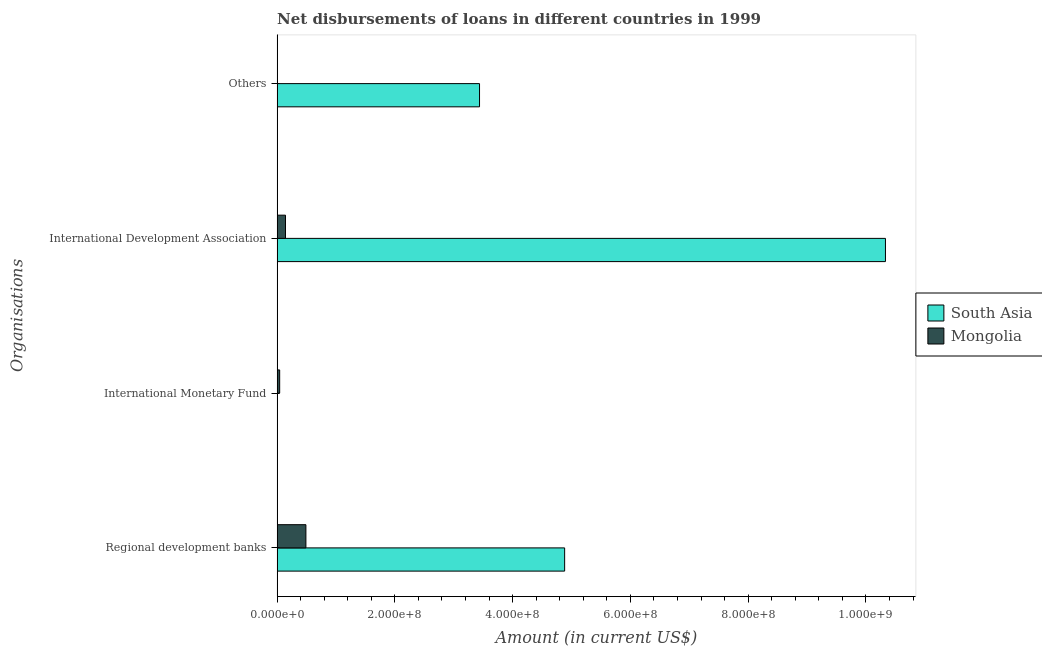How many different coloured bars are there?
Give a very brief answer. 2. Are the number of bars per tick equal to the number of legend labels?
Give a very brief answer. No. Are the number of bars on each tick of the Y-axis equal?
Keep it short and to the point. No. How many bars are there on the 4th tick from the top?
Ensure brevity in your answer.  2. How many bars are there on the 4th tick from the bottom?
Keep it short and to the point. 2. What is the label of the 1st group of bars from the top?
Offer a terse response. Others. What is the amount of loan disimbursed by other organisations in South Asia?
Ensure brevity in your answer.  3.44e+08. Across all countries, what is the maximum amount of loan disimbursed by other organisations?
Provide a short and direct response. 3.44e+08. Across all countries, what is the minimum amount of loan disimbursed by regional development banks?
Offer a very short reply. 4.89e+07. In which country was the amount of loan disimbursed by international development association maximum?
Your answer should be very brief. South Asia. What is the total amount of loan disimbursed by international development association in the graph?
Your answer should be very brief. 1.05e+09. What is the difference between the amount of loan disimbursed by other organisations in South Asia and that in Mongolia?
Offer a terse response. 3.43e+08. What is the difference between the amount of loan disimbursed by international monetary fund in Mongolia and the amount of loan disimbursed by other organisations in South Asia?
Offer a very short reply. -3.39e+08. What is the average amount of loan disimbursed by regional development banks per country?
Offer a terse response. 2.69e+08. What is the difference between the amount of loan disimbursed by regional development banks and amount of loan disimbursed by international development association in Mongolia?
Your answer should be very brief. 3.47e+07. What is the ratio of the amount of loan disimbursed by other organisations in Mongolia to that in South Asia?
Provide a short and direct response. 0. Is the amount of loan disimbursed by other organisations in South Asia less than that in Mongolia?
Provide a short and direct response. No. What is the difference between the highest and the second highest amount of loan disimbursed by international development association?
Make the answer very short. 1.02e+09. What is the difference between the highest and the lowest amount of loan disimbursed by other organisations?
Offer a very short reply. 3.43e+08. In how many countries, is the amount of loan disimbursed by international monetary fund greater than the average amount of loan disimbursed by international monetary fund taken over all countries?
Your answer should be compact. 1. Is it the case that in every country, the sum of the amount of loan disimbursed by regional development banks and amount of loan disimbursed by international monetary fund is greater than the amount of loan disimbursed by international development association?
Make the answer very short. No. Are all the bars in the graph horizontal?
Provide a short and direct response. Yes. How many countries are there in the graph?
Your answer should be very brief. 2. What is the difference between two consecutive major ticks on the X-axis?
Offer a terse response. 2.00e+08. Does the graph contain any zero values?
Make the answer very short. Yes. Where does the legend appear in the graph?
Provide a short and direct response. Center right. How many legend labels are there?
Your answer should be very brief. 2. What is the title of the graph?
Keep it short and to the point. Net disbursements of loans in different countries in 1999. What is the label or title of the Y-axis?
Offer a terse response. Organisations. What is the Amount (in current US$) of South Asia in Regional development banks?
Provide a succinct answer. 4.88e+08. What is the Amount (in current US$) of Mongolia in Regional development banks?
Offer a terse response. 4.89e+07. What is the Amount (in current US$) in South Asia in International Monetary Fund?
Your answer should be very brief. 0. What is the Amount (in current US$) in Mongolia in International Monetary Fund?
Your answer should be compact. 4.31e+06. What is the Amount (in current US$) of South Asia in International Development Association?
Keep it short and to the point. 1.03e+09. What is the Amount (in current US$) of Mongolia in International Development Association?
Offer a terse response. 1.42e+07. What is the Amount (in current US$) in South Asia in Others?
Keep it short and to the point. 3.44e+08. What is the Amount (in current US$) in Mongolia in Others?
Your answer should be very brief. 5.68e+05. Across all Organisations, what is the maximum Amount (in current US$) of South Asia?
Provide a succinct answer. 1.03e+09. Across all Organisations, what is the maximum Amount (in current US$) of Mongolia?
Provide a succinct answer. 4.89e+07. Across all Organisations, what is the minimum Amount (in current US$) of South Asia?
Make the answer very short. 0. Across all Organisations, what is the minimum Amount (in current US$) in Mongolia?
Ensure brevity in your answer.  5.68e+05. What is the total Amount (in current US$) in South Asia in the graph?
Provide a short and direct response. 1.87e+09. What is the total Amount (in current US$) of Mongolia in the graph?
Give a very brief answer. 6.80e+07. What is the difference between the Amount (in current US$) of Mongolia in Regional development banks and that in International Monetary Fund?
Make the answer very short. 4.46e+07. What is the difference between the Amount (in current US$) of South Asia in Regional development banks and that in International Development Association?
Your answer should be very brief. -5.45e+08. What is the difference between the Amount (in current US$) of Mongolia in Regional development banks and that in International Development Association?
Offer a terse response. 3.47e+07. What is the difference between the Amount (in current US$) in South Asia in Regional development banks and that in Others?
Provide a short and direct response. 1.45e+08. What is the difference between the Amount (in current US$) in Mongolia in Regional development banks and that in Others?
Offer a very short reply. 4.83e+07. What is the difference between the Amount (in current US$) of Mongolia in International Monetary Fund and that in International Development Association?
Offer a terse response. -9.91e+06. What is the difference between the Amount (in current US$) of Mongolia in International Monetary Fund and that in Others?
Offer a very short reply. 3.74e+06. What is the difference between the Amount (in current US$) in South Asia in International Development Association and that in Others?
Your answer should be very brief. 6.89e+08. What is the difference between the Amount (in current US$) in Mongolia in International Development Association and that in Others?
Give a very brief answer. 1.37e+07. What is the difference between the Amount (in current US$) in South Asia in Regional development banks and the Amount (in current US$) in Mongolia in International Monetary Fund?
Make the answer very short. 4.84e+08. What is the difference between the Amount (in current US$) in South Asia in Regional development banks and the Amount (in current US$) in Mongolia in International Development Association?
Your answer should be compact. 4.74e+08. What is the difference between the Amount (in current US$) of South Asia in Regional development banks and the Amount (in current US$) of Mongolia in Others?
Keep it short and to the point. 4.88e+08. What is the difference between the Amount (in current US$) of South Asia in International Development Association and the Amount (in current US$) of Mongolia in Others?
Keep it short and to the point. 1.03e+09. What is the average Amount (in current US$) of South Asia per Organisations?
Ensure brevity in your answer.  4.66e+08. What is the average Amount (in current US$) in Mongolia per Organisations?
Your answer should be compact. 1.70e+07. What is the difference between the Amount (in current US$) in South Asia and Amount (in current US$) in Mongolia in Regional development banks?
Ensure brevity in your answer.  4.39e+08. What is the difference between the Amount (in current US$) of South Asia and Amount (in current US$) of Mongolia in International Development Association?
Give a very brief answer. 1.02e+09. What is the difference between the Amount (in current US$) of South Asia and Amount (in current US$) of Mongolia in Others?
Your answer should be very brief. 3.43e+08. What is the ratio of the Amount (in current US$) in Mongolia in Regional development banks to that in International Monetary Fund?
Your answer should be compact. 11.34. What is the ratio of the Amount (in current US$) in South Asia in Regional development banks to that in International Development Association?
Make the answer very short. 0.47. What is the ratio of the Amount (in current US$) of Mongolia in Regional development banks to that in International Development Association?
Ensure brevity in your answer.  3.44. What is the ratio of the Amount (in current US$) in South Asia in Regional development banks to that in Others?
Provide a short and direct response. 1.42. What is the ratio of the Amount (in current US$) in Mongolia in Regional development banks to that in Others?
Make the answer very short. 86.06. What is the ratio of the Amount (in current US$) in Mongolia in International Monetary Fund to that in International Development Association?
Keep it short and to the point. 0.3. What is the ratio of the Amount (in current US$) of Mongolia in International Monetary Fund to that in Others?
Keep it short and to the point. 7.59. What is the ratio of the Amount (in current US$) of South Asia in International Development Association to that in Others?
Offer a terse response. 3.01. What is the ratio of the Amount (in current US$) of Mongolia in International Development Association to that in Others?
Make the answer very short. 25.04. What is the difference between the highest and the second highest Amount (in current US$) in South Asia?
Offer a very short reply. 5.45e+08. What is the difference between the highest and the second highest Amount (in current US$) in Mongolia?
Your answer should be very brief. 3.47e+07. What is the difference between the highest and the lowest Amount (in current US$) in South Asia?
Provide a succinct answer. 1.03e+09. What is the difference between the highest and the lowest Amount (in current US$) in Mongolia?
Keep it short and to the point. 4.83e+07. 